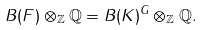Convert formula to latex. <formula><loc_0><loc_0><loc_500><loc_500>B ( F ) \otimes _ { \mathbb { Z } } \mathbb { Q } = B ( K ) ^ { G } \otimes _ { \mathbb { Z } } \mathbb { Q } .</formula> 